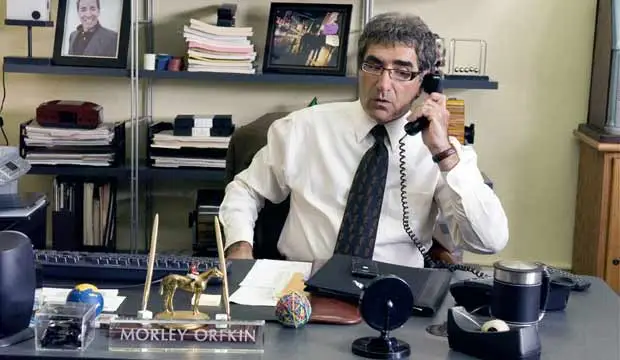What are your thoughts on the decorations on the desk? The decorations on the desk tell a unique story about the character's personality and interests. The gold camel statue stands out as an intriguing piece, possibly indicative of travel or a fondness for exotic items. The blue coffee mug suggests a regular coffee drinker, which isn't unusual in an office environment, while the black desk lamp appears to be a practical addition for late-night work sessions. The assortment of papers and office supplies adds to the portrait of someone deeply immersed in their work. How could the office setting be improved for better productivity? To enhance productivity, the office setting could benefit from better organization. Implementing a more effective filing system for the papers and documents on the desk could help reduce clutter and make it easier to find necessary items quickly. Upgrading the black desk lamp to a model with adjustable brightness and color temperatures could improve working conditions by reducing eye strain. Additionally, introducing some greenery, such as a small plant, could enhance the atmosphere and provide a calming presence in the office. 